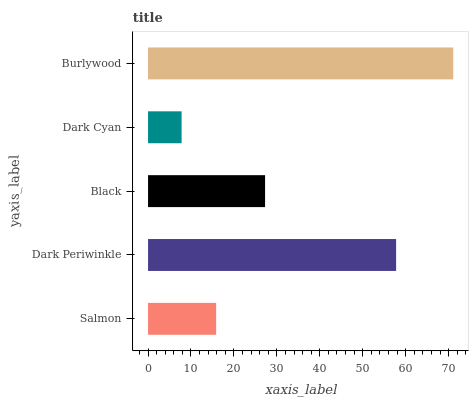Is Dark Cyan the minimum?
Answer yes or no. Yes. Is Burlywood the maximum?
Answer yes or no. Yes. Is Dark Periwinkle the minimum?
Answer yes or no. No. Is Dark Periwinkle the maximum?
Answer yes or no. No. Is Dark Periwinkle greater than Salmon?
Answer yes or no. Yes. Is Salmon less than Dark Periwinkle?
Answer yes or no. Yes. Is Salmon greater than Dark Periwinkle?
Answer yes or no. No. Is Dark Periwinkle less than Salmon?
Answer yes or no. No. Is Black the high median?
Answer yes or no. Yes. Is Black the low median?
Answer yes or no. Yes. Is Dark Cyan the high median?
Answer yes or no. No. Is Burlywood the low median?
Answer yes or no. No. 